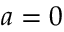<formula> <loc_0><loc_0><loc_500><loc_500>a = 0</formula> 